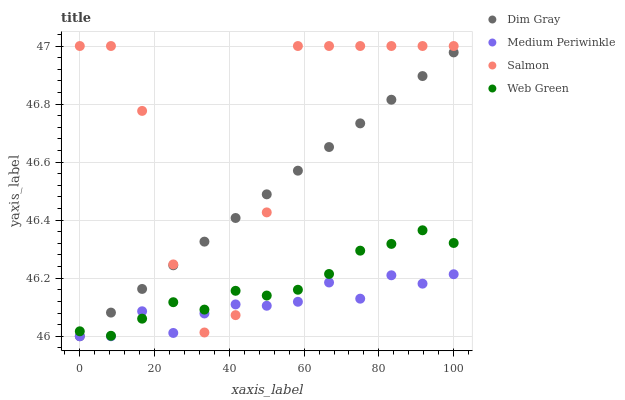Does Medium Periwinkle have the minimum area under the curve?
Answer yes or no. Yes. Does Salmon have the maximum area under the curve?
Answer yes or no. Yes. Does Dim Gray have the minimum area under the curve?
Answer yes or no. No. Does Dim Gray have the maximum area under the curve?
Answer yes or no. No. Is Dim Gray the smoothest?
Answer yes or no. Yes. Is Salmon the roughest?
Answer yes or no. Yes. Is Medium Periwinkle the smoothest?
Answer yes or no. No. Is Medium Periwinkle the roughest?
Answer yes or no. No. Does Dim Gray have the lowest value?
Answer yes or no. Yes. Does Web Green have the lowest value?
Answer yes or no. No. Does Salmon have the highest value?
Answer yes or no. Yes. Does Dim Gray have the highest value?
Answer yes or no. No. Does Dim Gray intersect Salmon?
Answer yes or no. Yes. Is Dim Gray less than Salmon?
Answer yes or no. No. Is Dim Gray greater than Salmon?
Answer yes or no. No. 